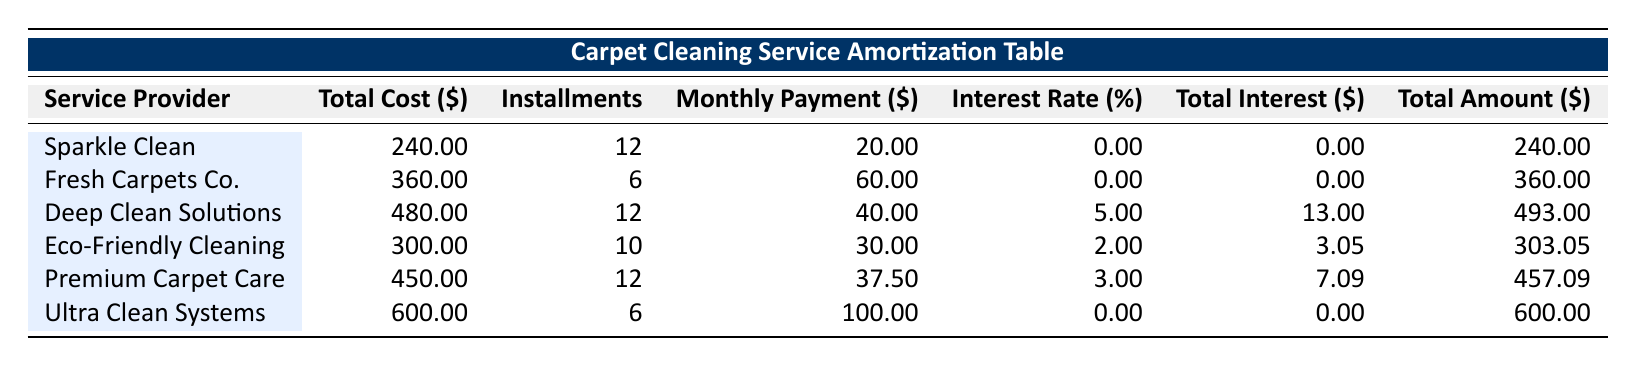What is the total cost of using Premium Carpet Care? The total cost for Premium Carpet Care is directly listed in the table under the "Total Cost ($)" column, which shows 450.
Answer: 450 How many installment payments are required for Eco-Friendly Cleaning? The table indicates that Eco-Friendly Cleaning requires 10 installments under the "Installments" column.
Answer: 10 Which service provider has the highest monthly payment? To determine this, we compare the "Monthly Payment ($)" column for all service providers. Ultra Clean Systems has the highest payment at 100.
Answer: 100 Is there any service provider that offers a payment plan with zero interest? By examining the "Interest Rate (%)" column, we see that Sparkle Clean, Fresh Carpets Co., and Ultra Clean Systems have an interest rate of 0, indicating they offer zero interest.
Answer: Yes What is the total amount paid over 12 months for Deep Clean Solutions? First, we identify the total cost for Deep Clean Solutions, which is 480. The table shows a total amount of 493, suggesting interest is included. Thus, after 12 months, you will pay 493.
Answer: 493 Which service provider has the lowest total interest paid? We need to look at the "Total Interest ($)" column and identify the lowest value. Sparkle Clean and Fresh Carpets Co. each show 0 interest, which is the lowest across all providers.
Answer: 0 What is the average monthly payment for all listed service providers? We calculate the average by adding all monthly payments: (20 + 60 + 40 + 30 + 37.50 + 100) = 287. We divide by the number of providers (6), resulting in an average of 47.83.
Answer: 47.83 If I choose Eco-Friendly Cleaning, how much will I pay in total over the installment plan? The total amount associated with Eco-Friendly Cleaning is listed in the "Total Amount ($)" column as 303.05, indicating this is the total payment made throughout the installments.
Answer: 303.05 Are there any payment plans that last longer than 10 installments? By reviewing the "Installments" column, we find that both Sparkle Clean and Deep Clean Solutions have 12 installments, confirming that these plans exceed 10 installments.
Answer: Yes 